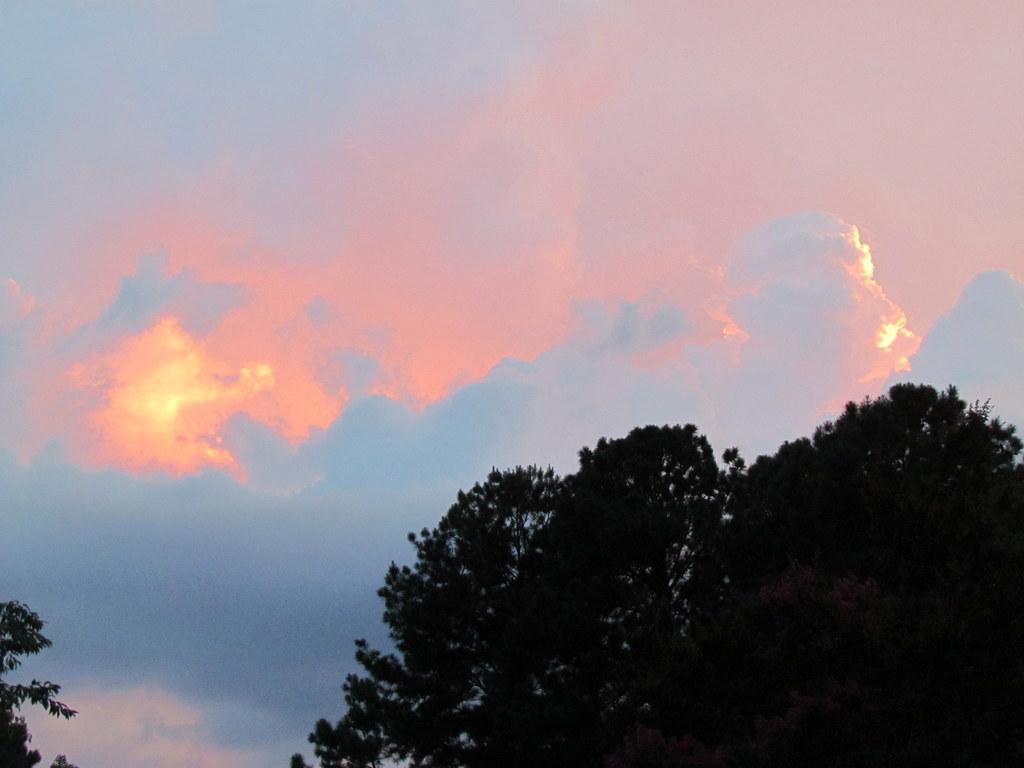Please provide a concise description of this image. In this image we can see the trees and clouds in the sky. 